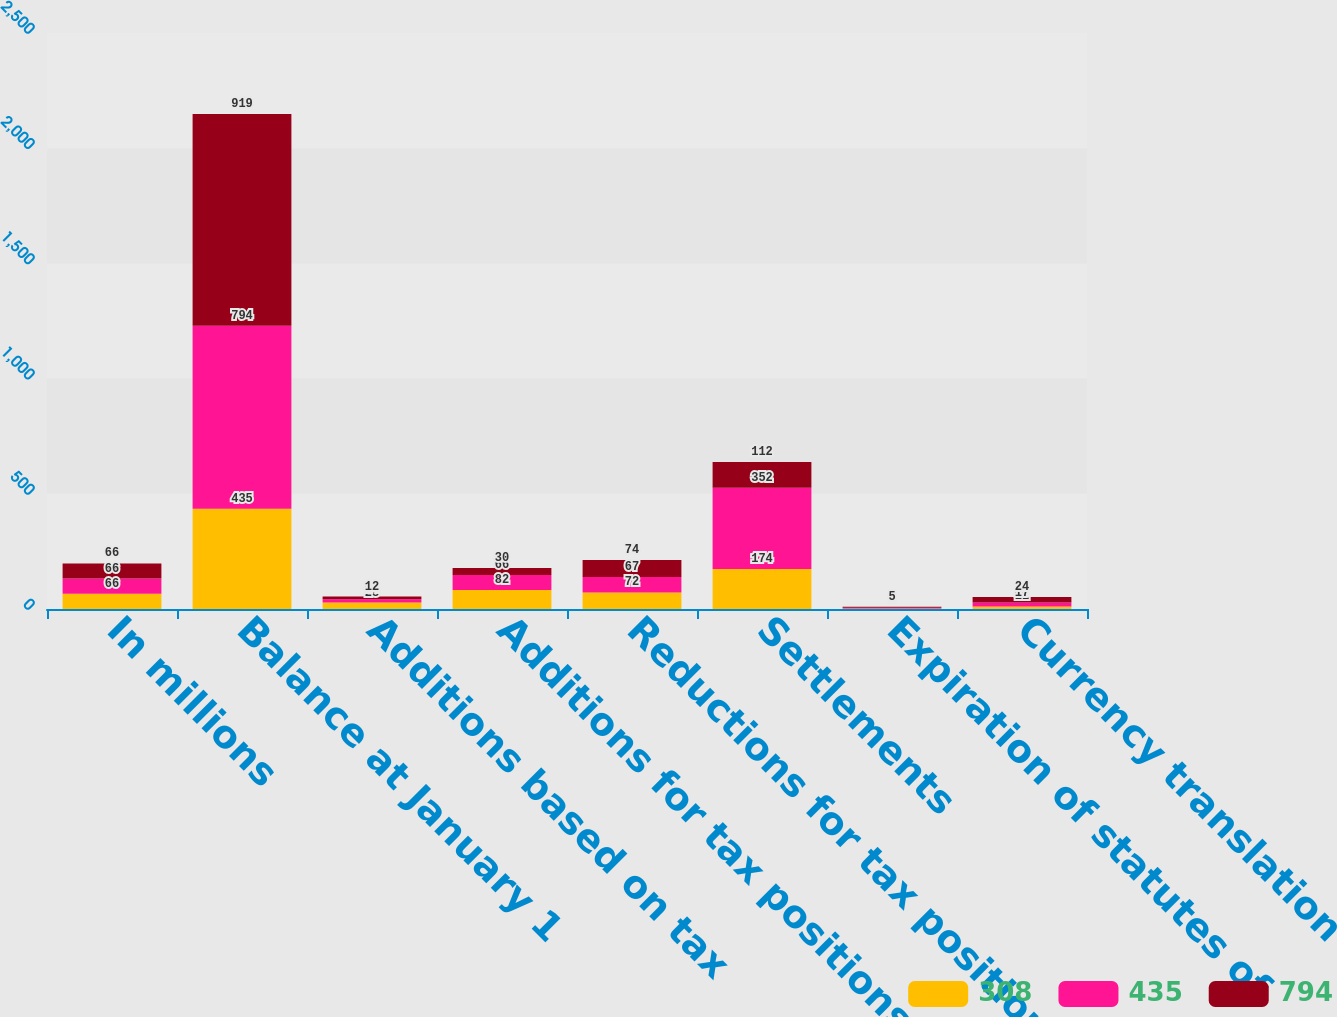Convert chart. <chart><loc_0><loc_0><loc_500><loc_500><stacked_bar_chart><ecel><fcel>In millions<fcel>Balance at January 1<fcel>Additions based on tax<fcel>Additions for tax positions of<fcel>Reductions for tax positions<fcel>Settlements<fcel>Expiration of statutes of<fcel>Currency translation<nl><fcel>308<fcel>66<fcel>435<fcel>28<fcel>82<fcel>72<fcel>174<fcel>2<fcel>11<nl><fcel>435<fcel>66<fcel>794<fcel>14<fcel>66<fcel>67<fcel>352<fcel>3<fcel>17<nl><fcel>794<fcel>66<fcel>919<fcel>12<fcel>30<fcel>74<fcel>112<fcel>5<fcel>24<nl></chart> 